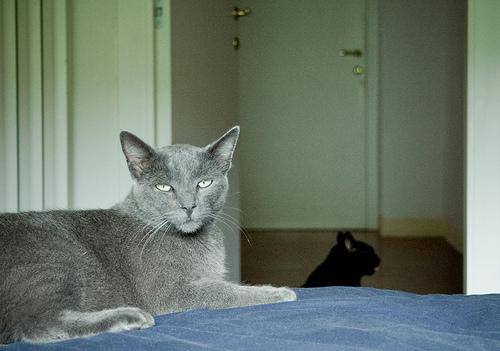Question: where was the picture taken?
Choices:
A. In a bathroom.
B. In a living room.
C. In a kitchen.
D. In a bedroom.
Answer with the letter. Answer: D Question: what color are the cats?
Choices:
A. Gray and black.
B. Orange and white.
C. Black and Brown.
D. Black and white.
Answer with the letter. Answer: A Question: where is the gray cat?
Choices:
A. On the blanket.
B. On the couch.
C. On the carpet.
D. On the desk.
Answer with the letter. Answer: A Question: how many cats are there?
Choices:
A. One.
B. Two.
C. Three.
D. Five.
Answer with the letter. Answer: B Question: what is under the gray cat?
Choices:
A. The table.
B. The blanket.
C. The counter.
D. The grass.
Answer with the letter. Answer: B 